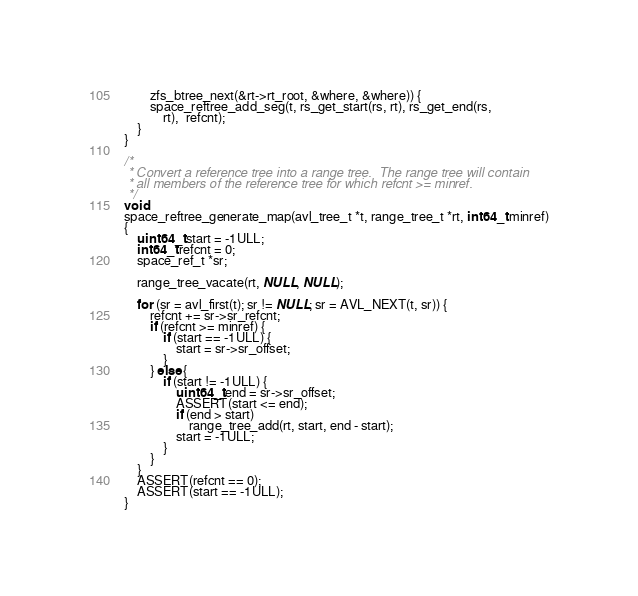<code> <loc_0><loc_0><loc_500><loc_500><_C_>	    zfs_btree_next(&rt->rt_root, &where, &where)) {
		space_reftree_add_seg(t, rs_get_start(rs, rt), rs_get_end(rs,
		    rt),  refcnt);
	}
}

/*
 * Convert a reference tree into a range tree.  The range tree will contain
 * all members of the reference tree for which refcnt >= minref.
 */
void
space_reftree_generate_map(avl_tree_t *t, range_tree_t *rt, int64_t minref)
{
	uint64_t start = -1ULL;
	int64_t refcnt = 0;
	space_ref_t *sr;

	range_tree_vacate(rt, NULL, NULL);

	for (sr = avl_first(t); sr != NULL; sr = AVL_NEXT(t, sr)) {
		refcnt += sr->sr_refcnt;
		if (refcnt >= minref) {
			if (start == -1ULL) {
				start = sr->sr_offset;
			}
		} else {
			if (start != -1ULL) {
				uint64_t end = sr->sr_offset;
				ASSERT(start <= end);
				if (end > start)
					range_tree_add(rt, start, end - start);
				start = -1ULL;
			}
		}
	}
	ASSERT(refcnt == 0);
	ASSERT(start == -1ULL);
}
</code> 